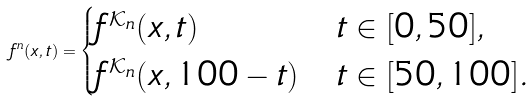Convert formula to latex. <formula><loc_0><loc_0><loc_500><loc_500>f ^ { n } ( x , t ) = \begin{cases} f ^ { \mathcal { K } _ { n } } ( x , t ) & t \in [ 0 , 5 0 ] , \\ f ^ { \mathcal { K } _ { n } } ( x , 1 0 0 - t ) & t \in [ 5 0 , 1 0 0 ] . \end{cases}</formula> 